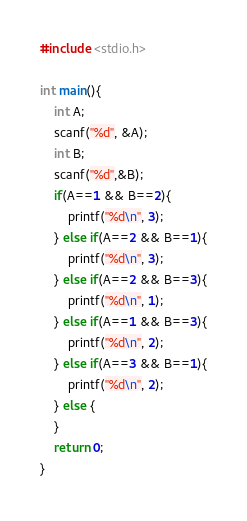Convert code to text. <code><loc_0><loc_0><loc_500><loc_500><_C_>#include <stdio.h>

int main(){
	int A;
	scanf("%d", &A);
	int B;
	scanf("%d",&B);
	if(A==1 && B==2){
		printf("%d\n", 3);
	} else if(A==2 && B==1){
		printf("%d\n", 3);
	} else if(A==2 && B==3){
		printf("%d\n", 1);
	} else if(A==1 && B==3){
		printf("%d\n", 2);
	} else if(A==3 && B==1){
		printf("%d\n", 2);
	} else {
	}
	return 0;
}</code> 